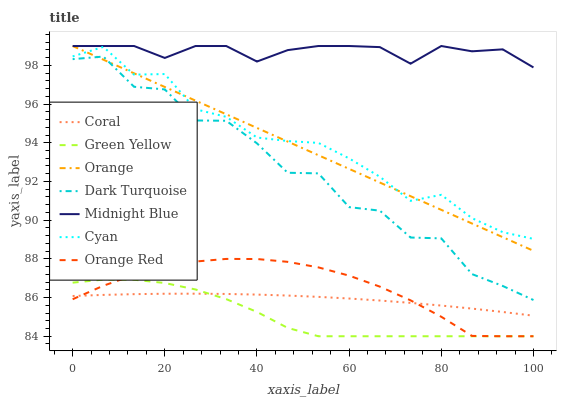Does Dark Turquoise have the minimum area under the curve?
Answer yes or no. No. Does Dark Turquoise have the maximum area under the curve?
Answer yes or no. No. Is Coral the smoothest?
Answer yes or no. No. Is Coral the roughest?
Answer yes or no. No. Does Dark Turquoise have the lowest value?
Answer yes or no. No. Does Dark Turquoise have the highest value?
Answer yes or no. No. Is Orange Red less than Orange?
Answer yes or no. Yes. Is Dark Turquoise greater than Green Yellow?
Answer yes or no. Yes. Does Orange Red intersect Orange?
Answer yes or no. No. 